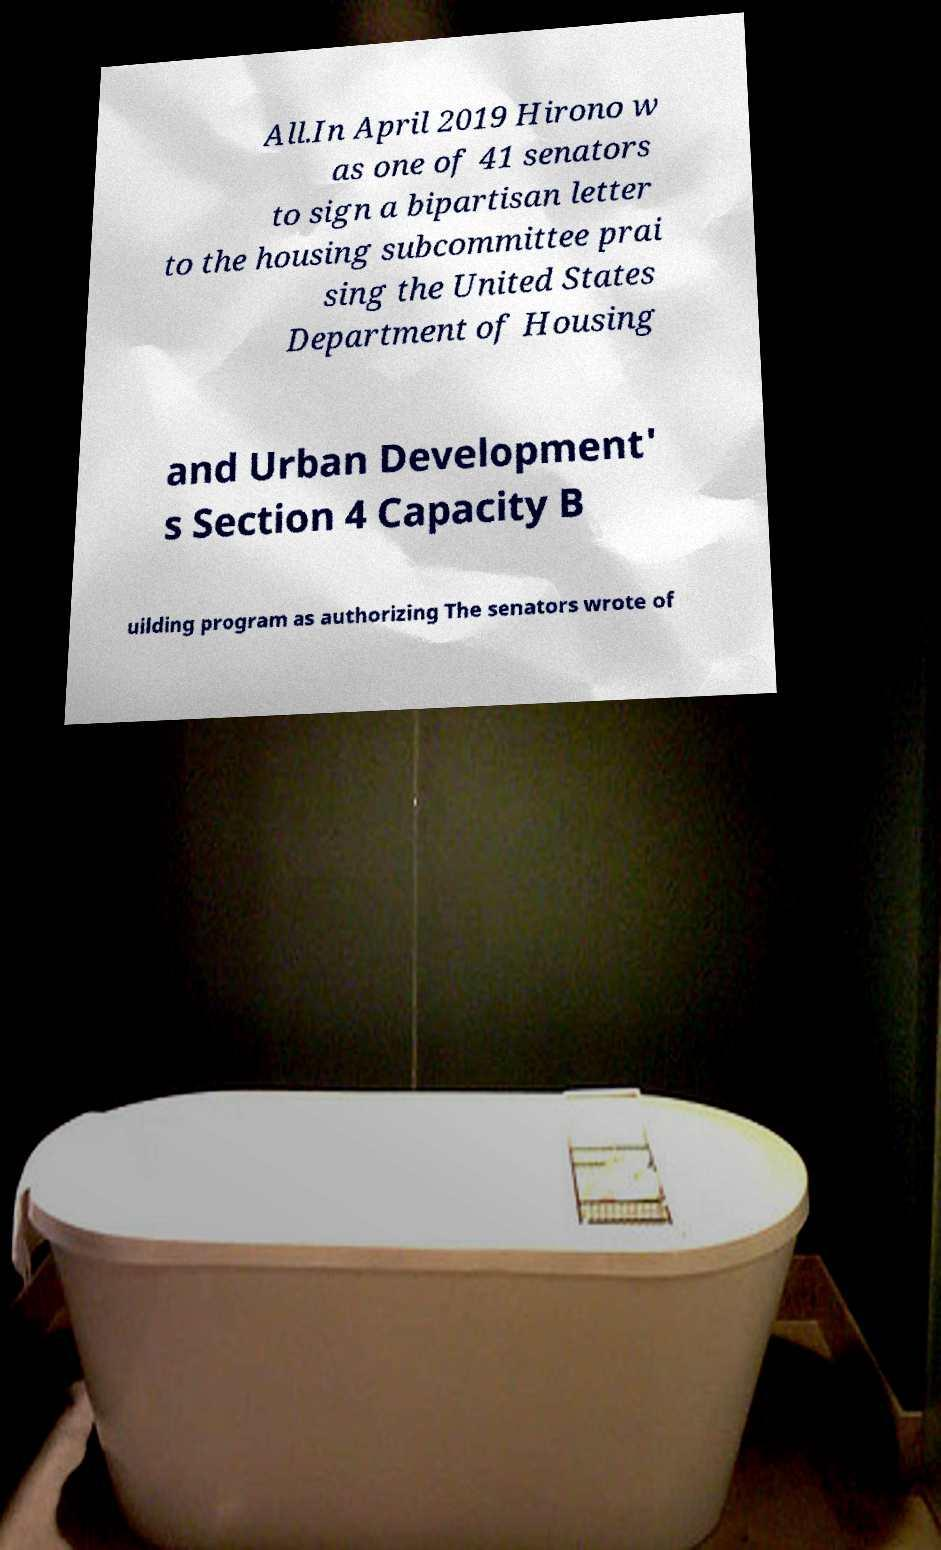Please read and relay the text visible in this image. What does it say? All.In April 2019 Hirono w as one of 41 senators to sign a bipartisan letter to the housing subcommittee prai sing the United States Department of Housing and Urban Development' s Section 4 Capacity B uilding program as authorizing The senators wrote of 